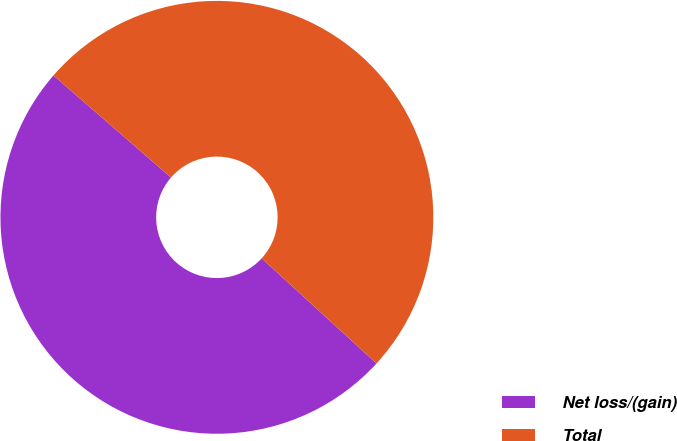Convert chart. <chart><loc_0><loc_0><loc_500><loc_500><pie_chart><fcel>Net loss/(gain)<fcel>Total<nl><fcel>49.58%<fcel>50.42%<nl></chart> 